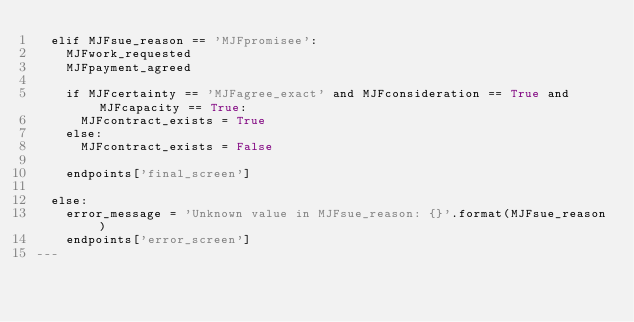Convert code to text. <code><loc_0><loc_0><loc_500><loc_500><_YAML_>  elif MJFsue_reason == 'MJFpromisee':
    MJFwork_requested
    MJFpayment_agreed

    if MJFcertainty == 'MJFagree_exact' and MJFconsideration == True and MJFcapacity == True:
      MJFcontract_exists = True
    else:
      MJFcontract_exists = False

    endpoints['final_screen']

  else:
    error_message = 'Unknown value in MJFsue_reason: {}'.format(MJFsue_reason)
    endpoints['error_screen']
---</code> 